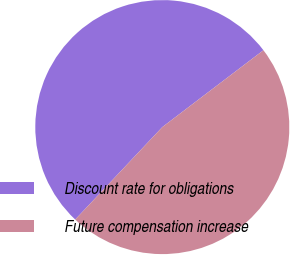<chart> <loc_0><loc_0><loc_500><loc_500><pie_chart><fcel>Discount rate for obligations<fcel>Future compensation increase<nl><fcel>52.63%<fcel>47.37%<nl></chart> 